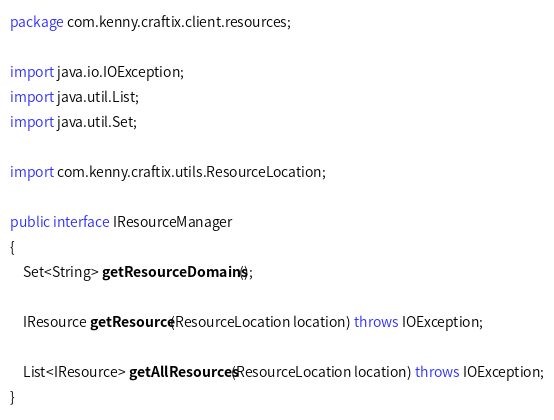<code> <loc_0><loc_0><loc_500><loc_500><_Java_>package com.kenny.craftix.client.resources;

import java.io.IOException;
import java.util.List;
import java.util.Set;

import com.kenny.craftix.utils.ResourceLocation;

public interface IResourceManager
{
    Set<String> getResourceDomains();

    IResource getResource(ResourceLocation location) throws IOException;

    List<IResource> getAllResources(ResourceLocation location) throws IOException;
}</code> 